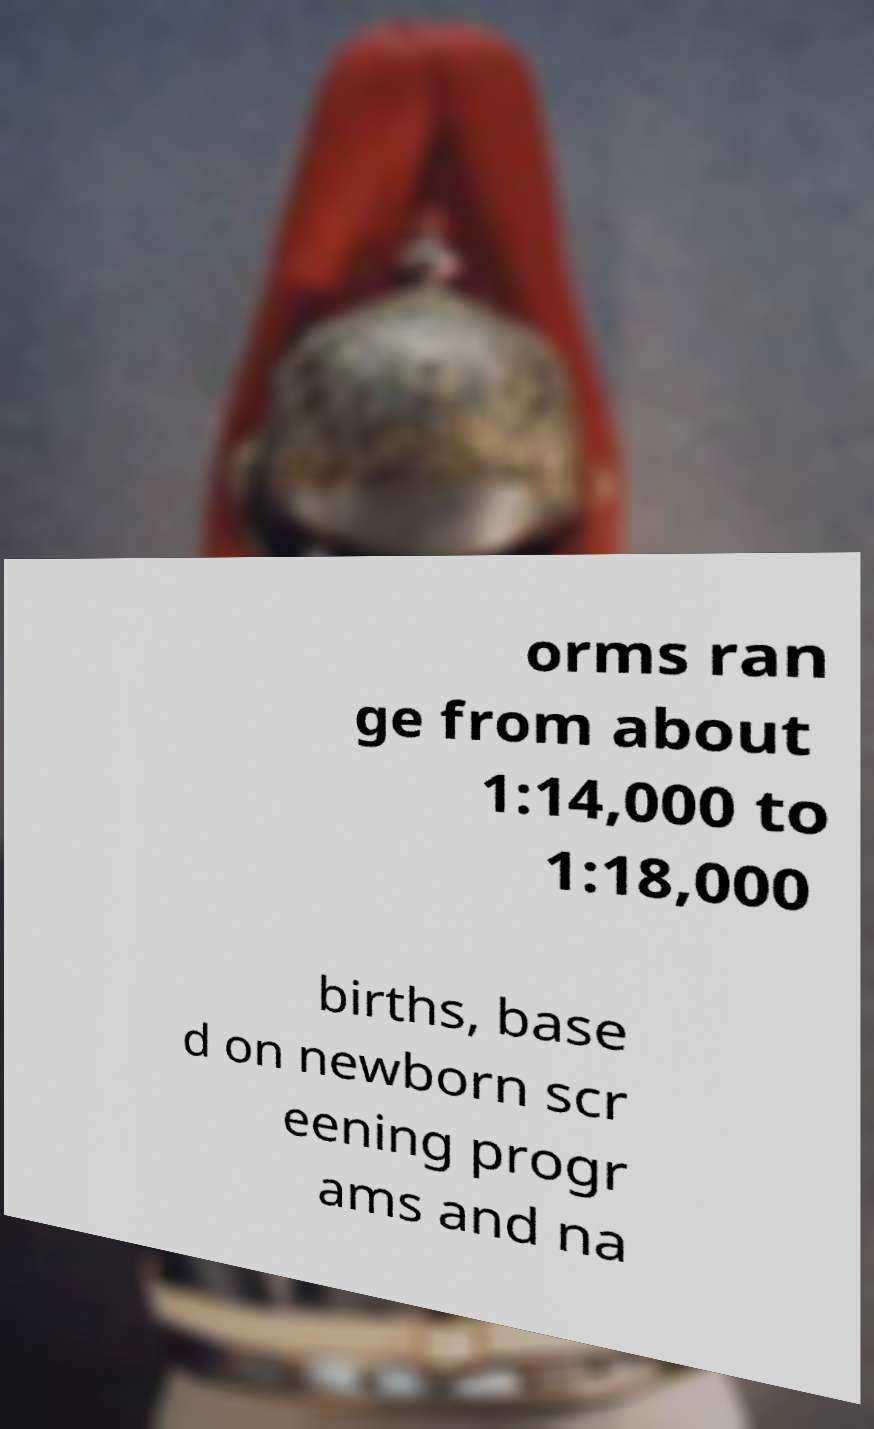There's text embedded in this image that I need extracted. Can you transcribe it verbatim? orms ran ge from about 1:14,000 to 1:18,000 births, base d on newborn scr eening progr ams and na 